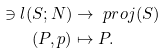Convert formula to latex. <formula><loc_0><loc_0><loc_500><loc_500>\ni l ( S ; N ) & \to \ p r o j ( S ) \\ ( P , p ) & \mapsto P . \\</formula> 